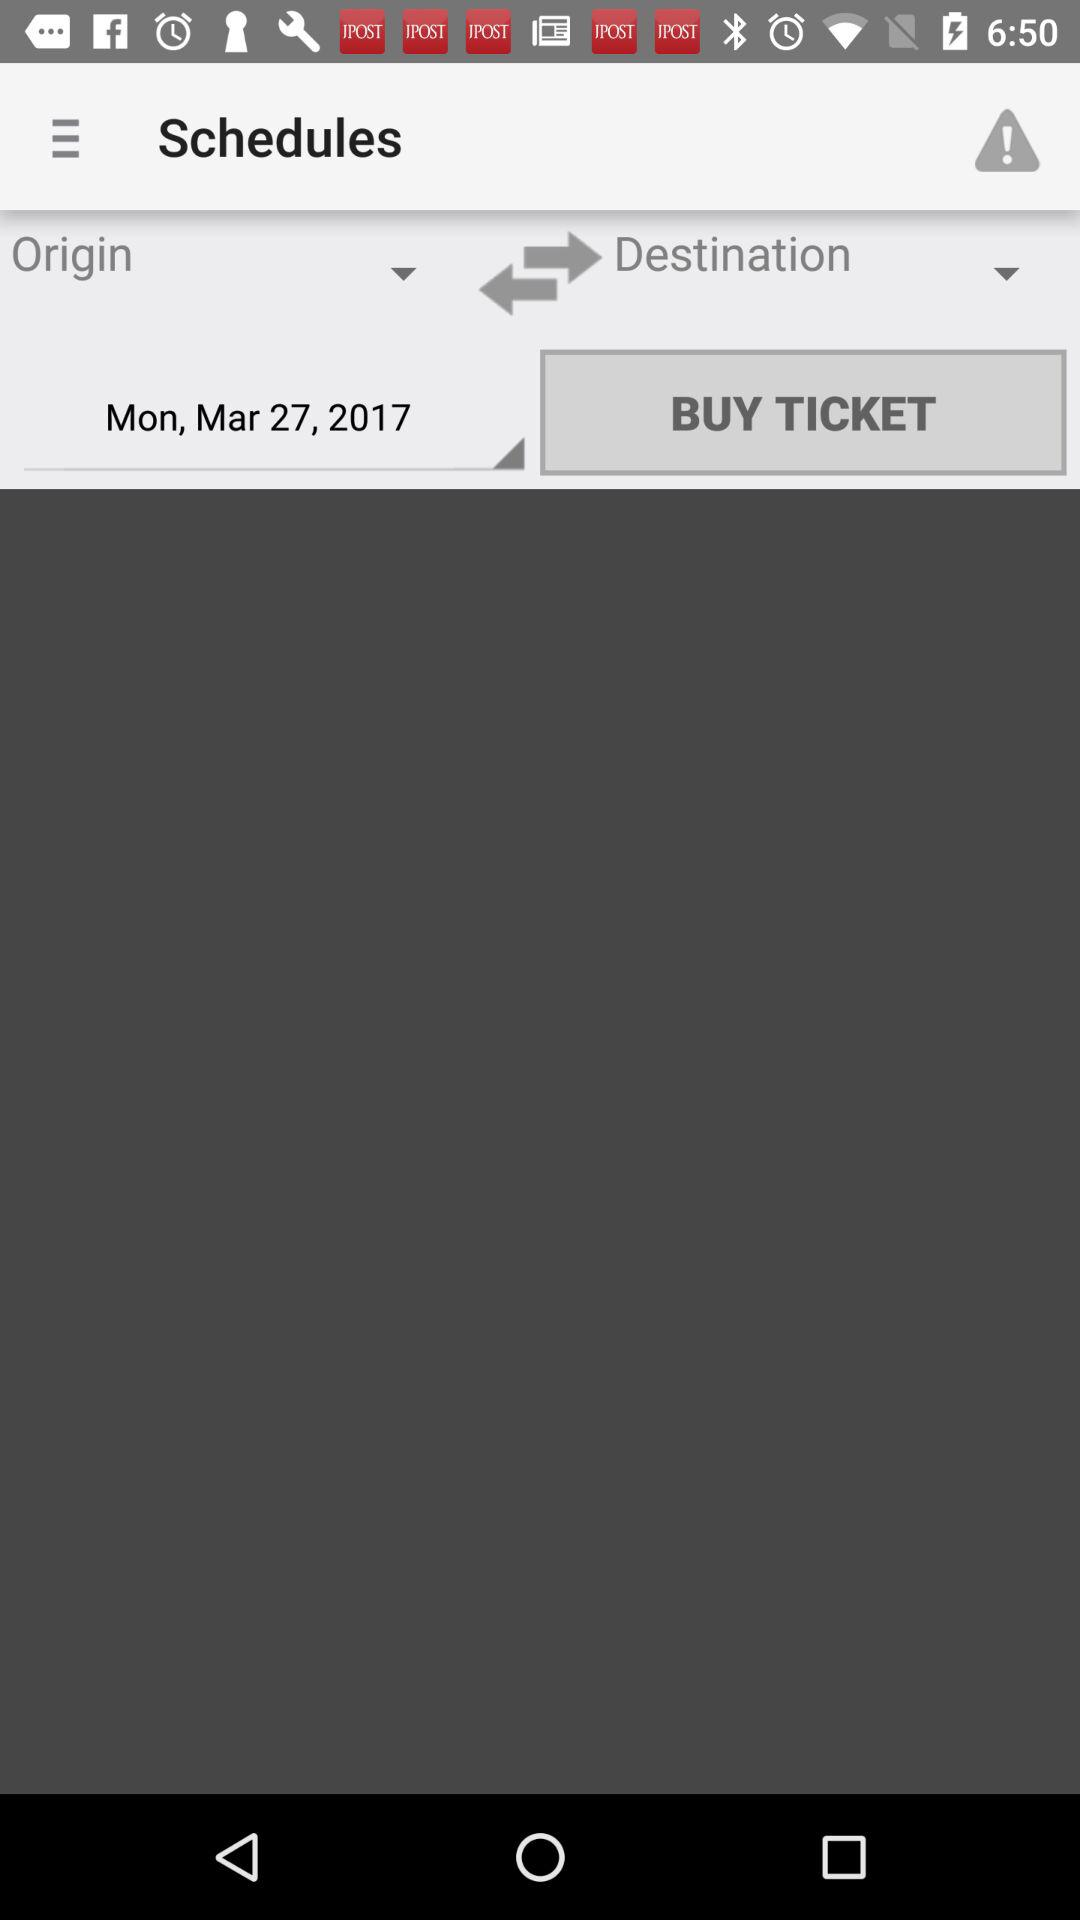What is the selected date? The selected date is Monday, March 27, 2017. 